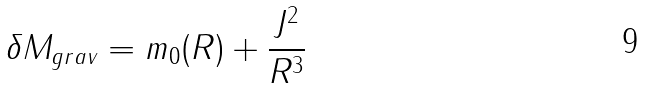Convert formula to latex. <formula><loc_0><loc_0><loc_500><loc_500>\delta M _ { g r a v } = m _ { 0 } ( R ) + \frac { J ^ { 2 } } { R ^ { 3 } }</formula> 